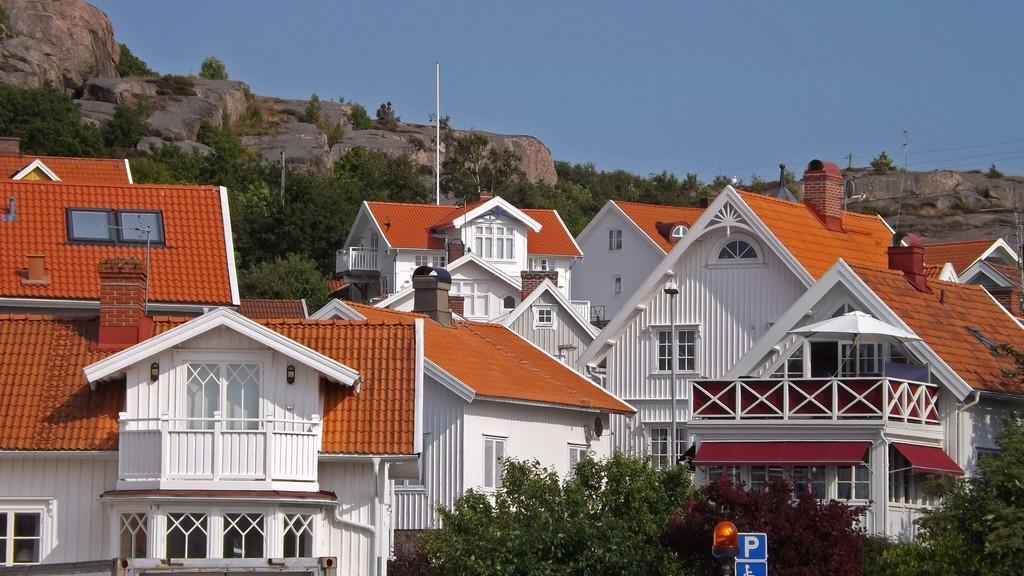In one or two sentences, can you explain what this image depicts? In this picture we can see some buildings, at the bottom there are some trees, we can see a board here, in the background there are some rocks, we can see the sky at the top of the picture. 